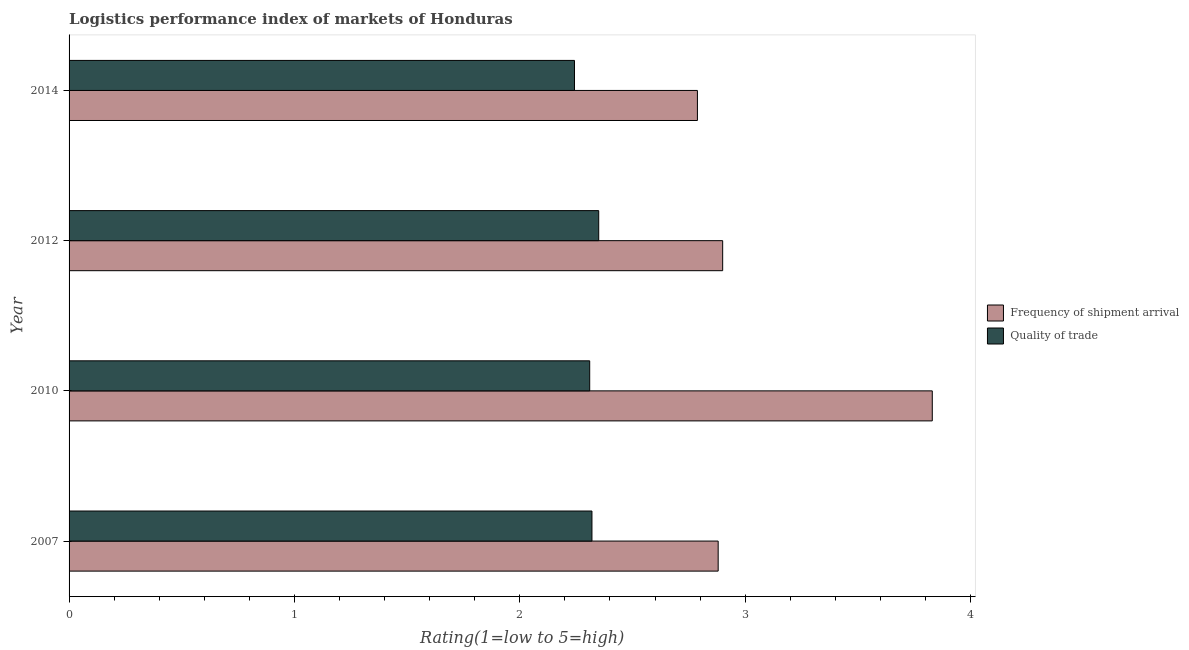Are the number of bars per tick equal to the number of legend labels?
Offer a very short reply. Yes. How many bars are there on the 2nd tick from the top?
Your answer should be compact. 2. What is the label of the 2nd group of bars from the top?
Your response must be concise. 2012. In how many cases, is the number of bars for a given year not equal to the number of legend labels?
Make the answer very short. 0. What is the lpi quality of trade in 2007?
Make the answer very short. 2.32. Across all years, what is the maximum lpi of frequency of shipment arrival?
Give a very brief answer. 3.83. Across all years, what is the minimum lpi quality of trade?
Your response must be concise. 2.24. What is the total lpi of frequency of shipment arrival in the graph?
Make the answer very short. 12.4. What is the difference between the lpi of frequency of shipment arrival in 2007 and that in 2012?
Ensure brevity in your answer.  -0.02. What is the difference between the lpi quality of trade in 2014 and the lpi of frequency of shipment arrival in 2007?
Your response must be concise. -0.64. What is the average lpi of frequency of shipment arrival per year?
Offer a terse response. 3.1. In the year 2014, what is the difference between the lpi of frequency of shipment arrival and lpi quality of trade?
Keep it short and to the point. 0.55. In how many years, is the lpi quality of trade greater than 3.2 ?
Your answer should be very brief. 0. Is the lpi of frequency of shipment arrival in 2007 less than that in 2012?
Give a very brief answer. Yes. Is the difference between the lpi of frequency of shipment arrival in 2007 and 2012 greater than the difference between the lpi quality of trade in 2007 and 2012?
Your answer should be very brief. Yes. What is the difference between the highest and the lowest lpi quality of trade?
Your response must be concise. 0.11. In how many years, is the lpi of frequency of shipment arrival greater than the average lpi of frequency of shipment arrival taken over all years?
Give a very brief answer. 1. Is the sum of the lpi quality of trade in 2007 and 2010 greater than the maximum lpi of frequency of shipment arrival across all years?
Your response must be concise. Yes. What does the 2nd bar from the top in 2007 represents?
Your response must be concise. Frequency of shipment arrival. What does the 2nd bar from the bottom in 2014 represents?
Your answer should be compact. Quality of trade. How many bars are there?
Provide a short and direct response. 8. Are all the bars in the graph horizontal?
Your answer should be very brief. Yes. What is the difference between two consecutive major ticks on the X-axis?
Give a very brief answer. 1. Does the graph contain any zero values?
Give a very brief answer. No. Where does the legend appear in the graph?
Offer a terse response. Center right. What is the title of the graph?
Offer a very short reply. Logistics performance index of markets of Honduras. What is the label or title of the X-axis?
Provide a succinct answer. Rating(1=low to 5=high). What is the label or title of the Y-axis?
Give a very brief answer. Year. What is the Rating(1=low to 5=high) in Frequency of shipment arrival in 2007?
Your response must be concise. 2.88. What is the Rating(1=low to 5=high) in Quality of trade in 2007?
Your answer should be compact. 2.32. What is the Rating(1=low to 5=high) of Frequency of shipment arrival in 2010?
Ensure brevity in your answer.  3.83. What is the Rating(1=low to 5=high) of Quality of trade in 2010?
Provide a short and direct response. 2.31. What is the Rating(1=low to 5=high) in Quality of trade in 2012?
Provide a short and direct response. 2.35. What is the Rating(1=low to 5=high) of Frequency of shipment arrival in 2014?
Make the answer very short. 2.79. What is the Rating(1=low to 5=high) in Quality of trade in 2014?
Your response must be concise. 2.24. Across all years, what is the maximum Rating(1=low to 5=high) in Frequency of shipment arrival?
Your response must be concise. 3.83. Across all years, what is the maximum Rating(1=low to 5=high) in Quality of trade?
Give a very brief answer. 2.35. Across all years, what is the minimum Rating(1=low to 5=high) of Frequency of shipment arrival?
Give a very brief answer. 2.79. Across all years, what is the minimum Rating(1=low to 5=high) in Quality of trade?
Your answer should be compact. 2.24. What is the total Rating(1=low to 5=high) in Frequency of shipment arrival in the graph?
Provide a succinct answer. 12.4. What is the total Rating(1=low to 5=high) in Quality of trade in the graph?
Offer a very short reply. 9.22. What is the difference between the Rating(1=low to 5=high) in Frequency of shipment arrival in 2007 and that in 2010?
Make the answer very short. -0.95. What is the difference between the Rating(1=low to 5=high) in Frequency of shipment arrival in 2007 and that in 2012?
Make the answer very short. -0.02. What is the difference between the Rating(1=low to 5=high) of Quality of trade in 2007 and that in 2012?
Make the answer very short. -0.03. What is the difference between the Rating(1=low to 5=high) in Frequency of shipment arrival in 2007 and that in 2014?
Your response must be concise. 0.09. What is the difference between the Rating(1=low to 5=high) in Quality of trade in 2007 and that in 2014?
Provide a short and direct response. 0.08. What is the difference between the Rating(1=low to 5=high) in Frequency of shipment arrival in 2010 and that in 2012?
Provide a succinct answer. 0.93. What is the difference between the Rating(1=low to 5=high) in Quality of trade in 2010 and that in 2012?
Provide a short and direct response. -0.04. What is the difference between the Rating(1=low to 5=high) of Frequency of shipment arrival in 2010 and that in 2014?
Make the answer very short. 1.04. What is the difference between the Rating(1=low to 5=high) in Quality of trade in 2010 and that in 2014?
Your answer should be very brief. 0.07. What is the difference between the Rating(1=low to 5=high) in Frequency of shipment arrival in 2012 and that in 2014?
Your response must be concise. 0.11. What is the difference between the Rating(1=low to 5=high) of Quality of trade in 2012 and that in 2014?
Provide a short and direct response. 0.11. What is the difference between the Rating(1=low to 5=high) of Frequency of shipment arrival in 2007 and the Rating(1=low to 5=high) of Quality of trade in 2010?
Offer a terse response. 0.57. What is the difference between the Rating(1=low to 5=high) in Frequency of shipment arrival in 2007 and the Rating(1=low to 5=high) in Quality of trade in 2012?
Keep it short and to the point. 0.53. What is the difference between the Rating(1=low to 5=high) in Frequency of shipment arrival in 2007 and the Rating(1=low to 5=high) in Quality of trade in 2014?
Your response must be concise. 0.64. What is the difference between the Rating(1=low to 5=high) of Frequency of shipment arrival in 2010 and the Rating(1=low to 5=high) of Quality of trade in 2012?
Your answer should be very brief. 1.48. What is the difference between the Rating(1=low to 5=high) of Frequency of shipment arrival in 2010 and the Rating(1=low to 5=high) of Quality of trade in 2014?
Keep it short and to the point. 1.59. What is the difference between the Rating(1=low to 5=high) in Frequency of shipment arrival in 2012 and the Rating(1=low to 5=high) in Quality of trade in 2014?
Make the answer very short. 0.66. What is the average Rating(1=low to 5=high) of Frequency of shipment arrival per year?
Give a very brief answer. 3.1. What is the average Rating(1=low to 5=high) of Quality of trade per year?
Provide a succinct answer. 2.31. In the year 2007, what is the difference between the Rating(1=low to 5=high) in Frequency of shipment arrival and Rating(1=low to 5=high) in Quality of trade?
Offer a very short reply. 0.56. In the year 2010, what is the difference between the Rating(1=low to 5=high) of Frequency of shipment arrival and Rating(1=low to 5=high) of Quality of trade?
Offer a terse response. 1.52. In the year 2012, what is the difference between the Rating(1=low to 5=high) of Frequency of shipment arrival and Rating(1=low to 5=high) of Quality of trade?
Your response must be concise. 0.55. In the year 2014, what is the difference between the Rating(1=low to 5=high) in Frequency of shipment arrival and Rating(1=low to 5=high) in Quality of trade?
Provide a short and direct response. 0.55. What is the ratio of the Rating(1=low to 5=high) of Frequency of shipment arrival in 2007 to that in 2010?
Make the answer very short. 0.75. What is the ratio of the Rating(1=low to 5=high) in Quality of trade in 2007 to that in 2010?
Ensure brevity in your answer.  1. What is the ratio of the Rating(1=low to 5=high) of Frequency of shipment arrival in 2007 to that in 2012?
Provide a succinct answer. 0.99. What is the ratio of the Rating(1=low to 5=high) in Quality of trade in 2007 to that in 2012?
Make the answer very short. 0.99. What is the ratio of the Rating(1=low to 5=high) of Frequency of shipment arrival in 2007 to that in 2014?
Keep it short and to the point. 1.03. What is the ratio of the Rating(1=low to 5=high) of Quality of trade in 2007 to that in 2014?
Your answer should be very brief. 1.03. What is the ratio of the Rating(1=low to 5=high) in Frequency of shipment arrival in 2010 to that in 2012?
Offer a terse response. 1.32. What is the ratio of the Rating(1=low to 5=high) in Quality of trade in 2010 to that in 2012?
Give a very brief answer. 0.98. What is the ratio of the Rating(1=low to 5=high) of Frequency of shipment arrival in 2010 to that in 2014?
Ensure brevity in your answer.  1.37. What is the ratio of the Rating(1=low to 5=high) in Quality of trade in 2010 to that in 2014?
Your response must be concise. 1.03. What is the ratio of the Rating(1=low to 5=high) in Frequency of shipment arrival in 2012 to that in 2014?
Give a very brief answer. 1.04. What is the ratio of the Rating(1=low to 5=high) of Quality of trade in 2012 to that in 2014?
Your response must be concise. 1.05. What is the difference between the highest and the lowest Rating(1=low to 5=high) of Frequency of shipment arrival?
Offer a terse response. 1.04. What is the difference between the highest and the lowest Rating(1=low to 5=high) of Quality of trade?
Your answer should be very brief. 0.11. 